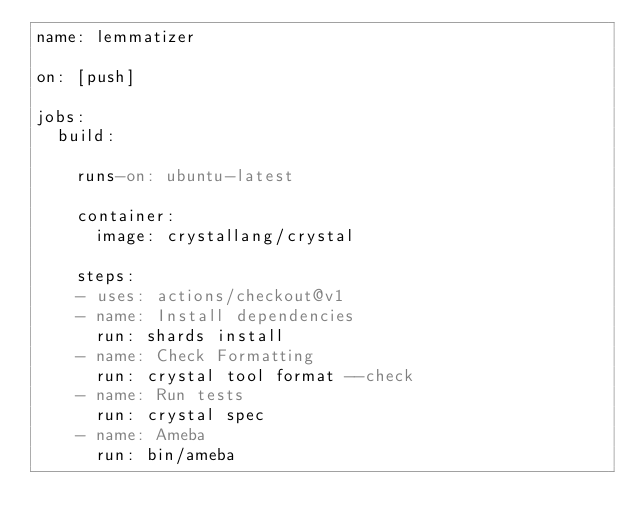<code> <loc_0><loc_0><loc_500><loc_500><_YAML_>name: lemmatizer

on: [push]

jobs:
  build:

    runs-on: ubuntu-latest
    
    container:
      image: crystallang/crystal
    
    steps:
    - uses: actions/checkout@v1
    - name: Install dependencies
      run: shards install
    - name: Check Formatting
      run: crystal tool format --check
    - name: Run tests
      run: crystal spec
    - name: Ameba
      run: bin/ameba
</code> 